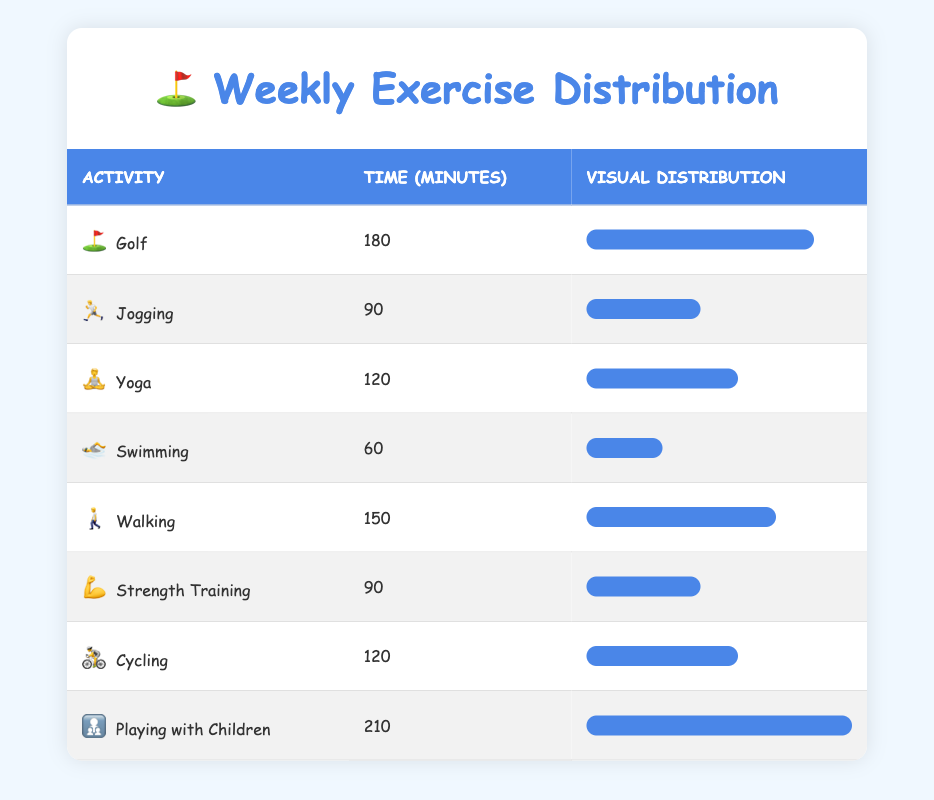What's the total time spent on playing with children and swimming? The time spent on playing with children is 210 minutes, and for swimming, it is 60 minutes. Adding these values gives us 210 + 60 = 270 minutes.
Answer: 270 minutes Which activity has the highest time spent per week? In the table, the activity with the highest time spent is playing with children, which is 210 minutes.
Answer: Playing with children Is the time spent on yoga greater than the time spent on cycling? Yoga takes 120 minutes while cycling also takes 120 minutes. Therefore, the time spent on yoga is not greater than that of cycling.
Answer: No What is the average time spent across all activities listed? To find the average, we first calculate the total time: 180 + 90 + 120 + 60 + 150 + 90 + 120 + 210 = 1020 minutes. Then, there are 8 activities, so the average is 1020/8 = 127.5 minutes.
Answer: 127.5 minutes How many activities have a time spent of 120 minutes or more? The activities with 120 minutes or more are golf (180), yoga (120), walking (150), cycling (120), and playing with children (210), totaling 5 activities.
Answer: 5 activities Is the time spent on walking less than the time spent on jogging? Walking takes 150 minutes, and jogging takes 90 minutes. Therefore, the time spent on walking is greater than that of jogging.
Answer: No What is the difference between the time spent on playing with children and golf? The time spent on playing with children is 210 minutes and for golf, it is 180 minutes. The difference is 210 - 180 = 30 minutes.
Answer: 30 minutes Which activities have the same amount of time spent per week? In the table, jogging and strength training both have a time spent of 90 minutes per week.
Answer: Jogging and strength training 